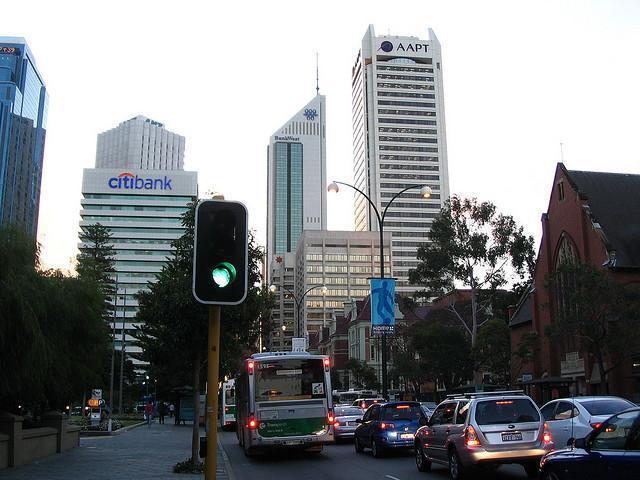How many cars are there?
Give a very brief answer. 4. How many human statues are to the left of the clock face?
Give a very brief answer. 0. 